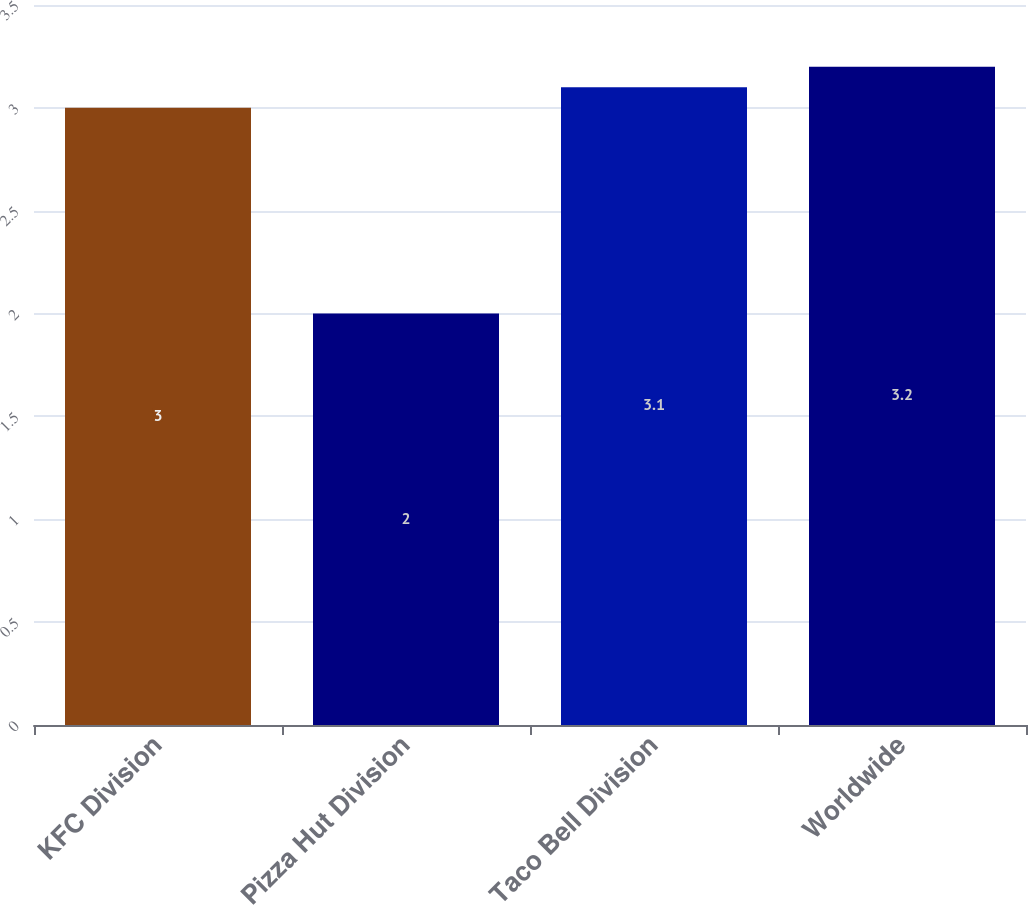Convert chart. <chart><loc_0><loc_0><loc_500><loc_500><bar_chart><fcel>KFC Division<fcel>Pizza Hut Division<fcel>Taco Bell Division<fcel>Worldwide<nl><fcel>3<fcel>2<fcel>3.1<fcel>3.2<nl></chart> 